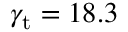Convert formula to latex. <formula><loc_0><loc_0><loc_500><loc_500>\gamma _ { t } = 1 8 . 3</formula> 